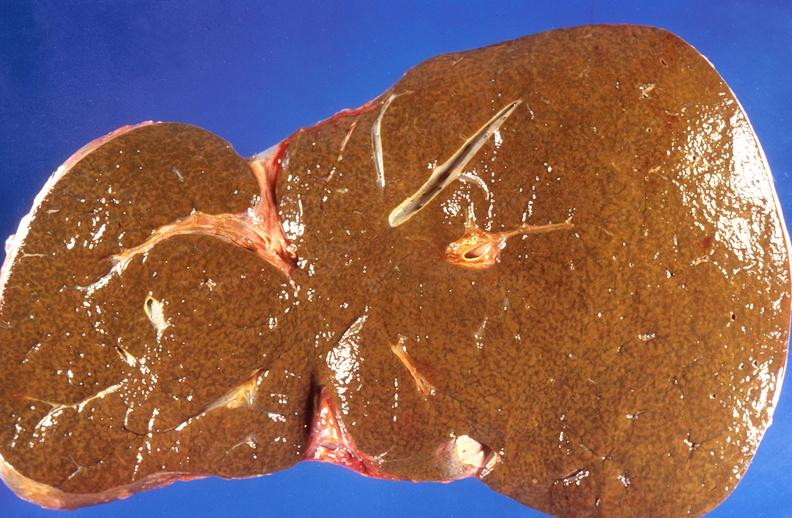s hepatobiliary present?
Answer the question using a single word or phrase. Yes 